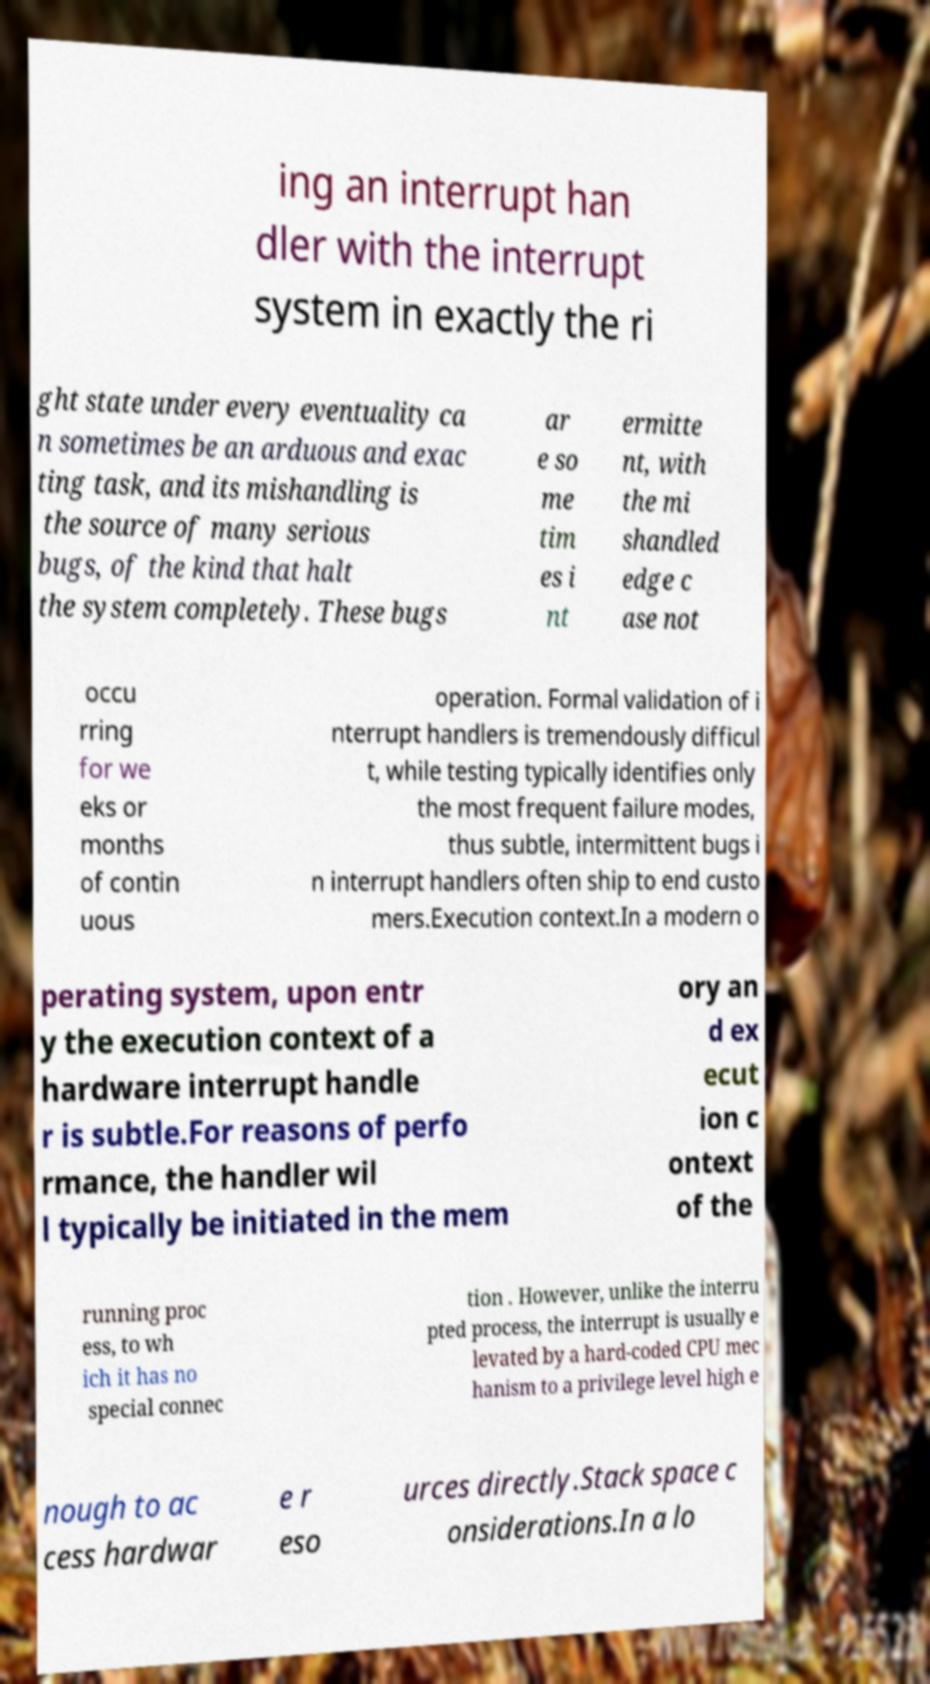Please identify and transcribe the text found in this image. ing an interrupt han dler with the interrupt system in exactly the ri ght state under every eventuality ca n sometimes be an arduous and exac ting task, and its mishandling is the source of many serious bugs, of the kind that halt the system completely. These bugs ar e so me tim es i nt ermitte nt, with the mi shandled edge c ase not occu rring for we eks or months of contin uous operation. Formal validation of i nterrupt handlers is tremendously difficul t, while testing typically identifies only the most frequent failure modes, thus subtle, intermittent bugs i n interrupt handlers often ship to end custo mers.Execution context.In a modern o perating system, upon entr y the execution context of a hardware interrupt handle r is subtle.For reasons of perfo rmance, the handler wil l typically be initiated in the mem ory an d ex ecut ion c ontext of the running proc ess, to wh ich it has no special connec tion . However, unlike the interru pted process, the interrupt is usually e levated by a hard-coded CPU mec hanism to a privilege level high e nough to ac cess hardwar e r eso urces directly.Stack space c onsiderations.In a lo 